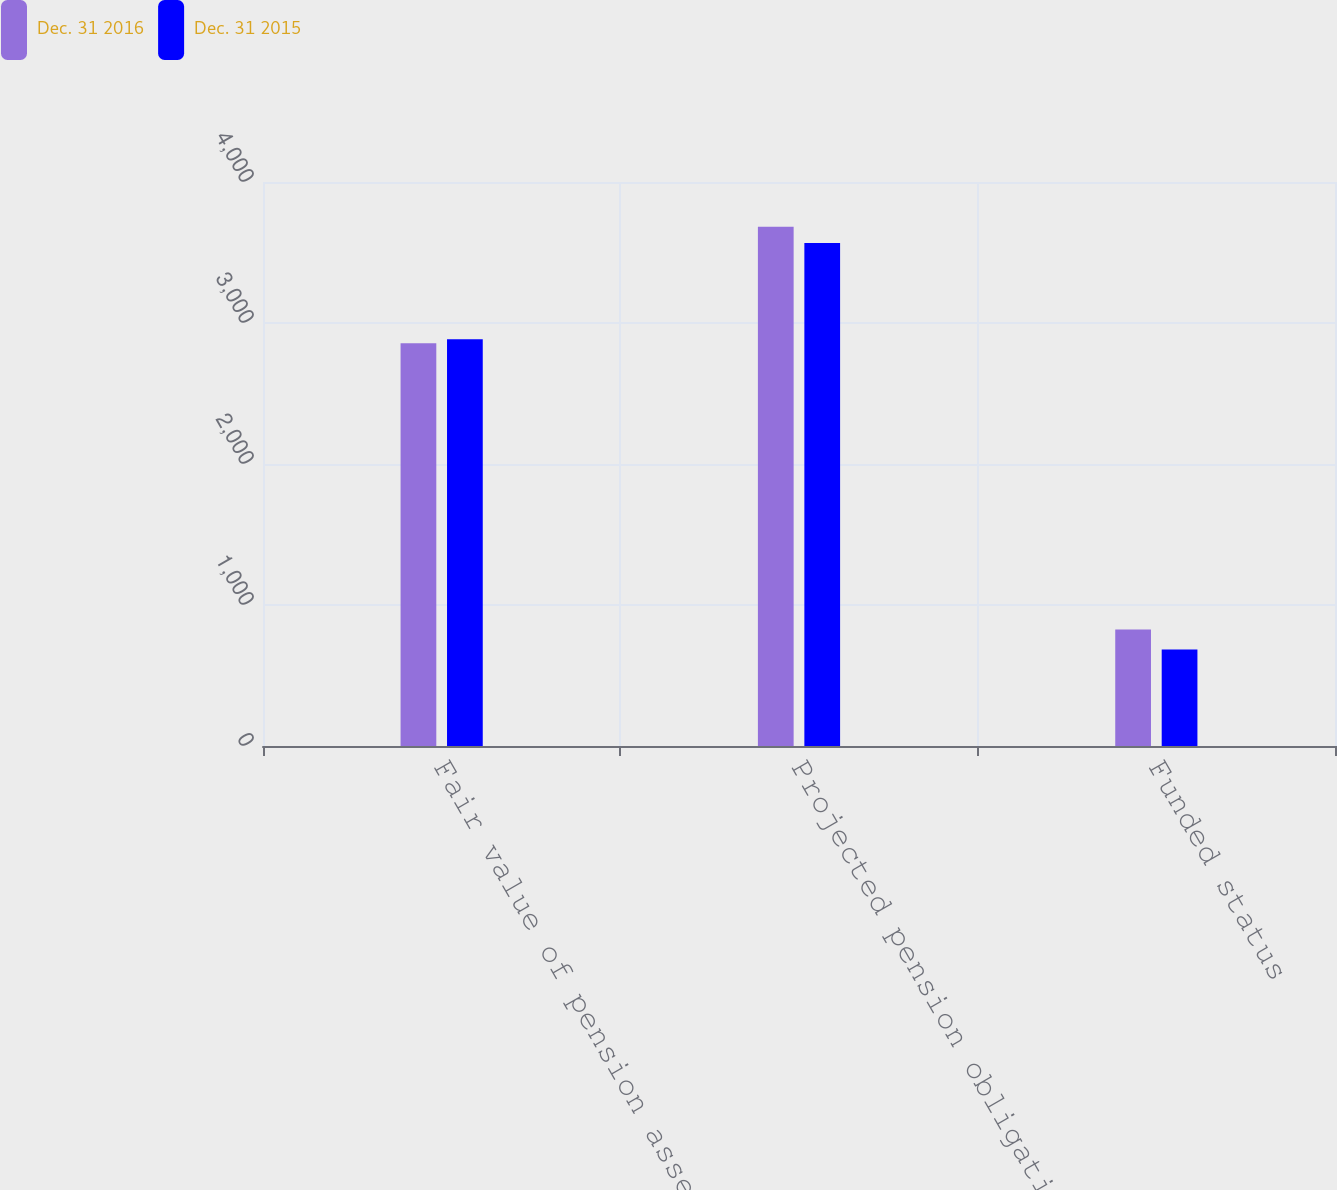<chart> <loc_0><loc_0><loc_500><loc_500><stacked_bar_chart><ecel><fcel>Fair value of pension assets<fcel>Projected pension obligation<fcel>Funded status<nl><fcel>Dec. 31 2016<fcel>2856<fcel>3682<fcel>826<nl><fcel>Dec. 31 2015<fcel>2884<fcel>3568<fcel>684<nl></chart> 